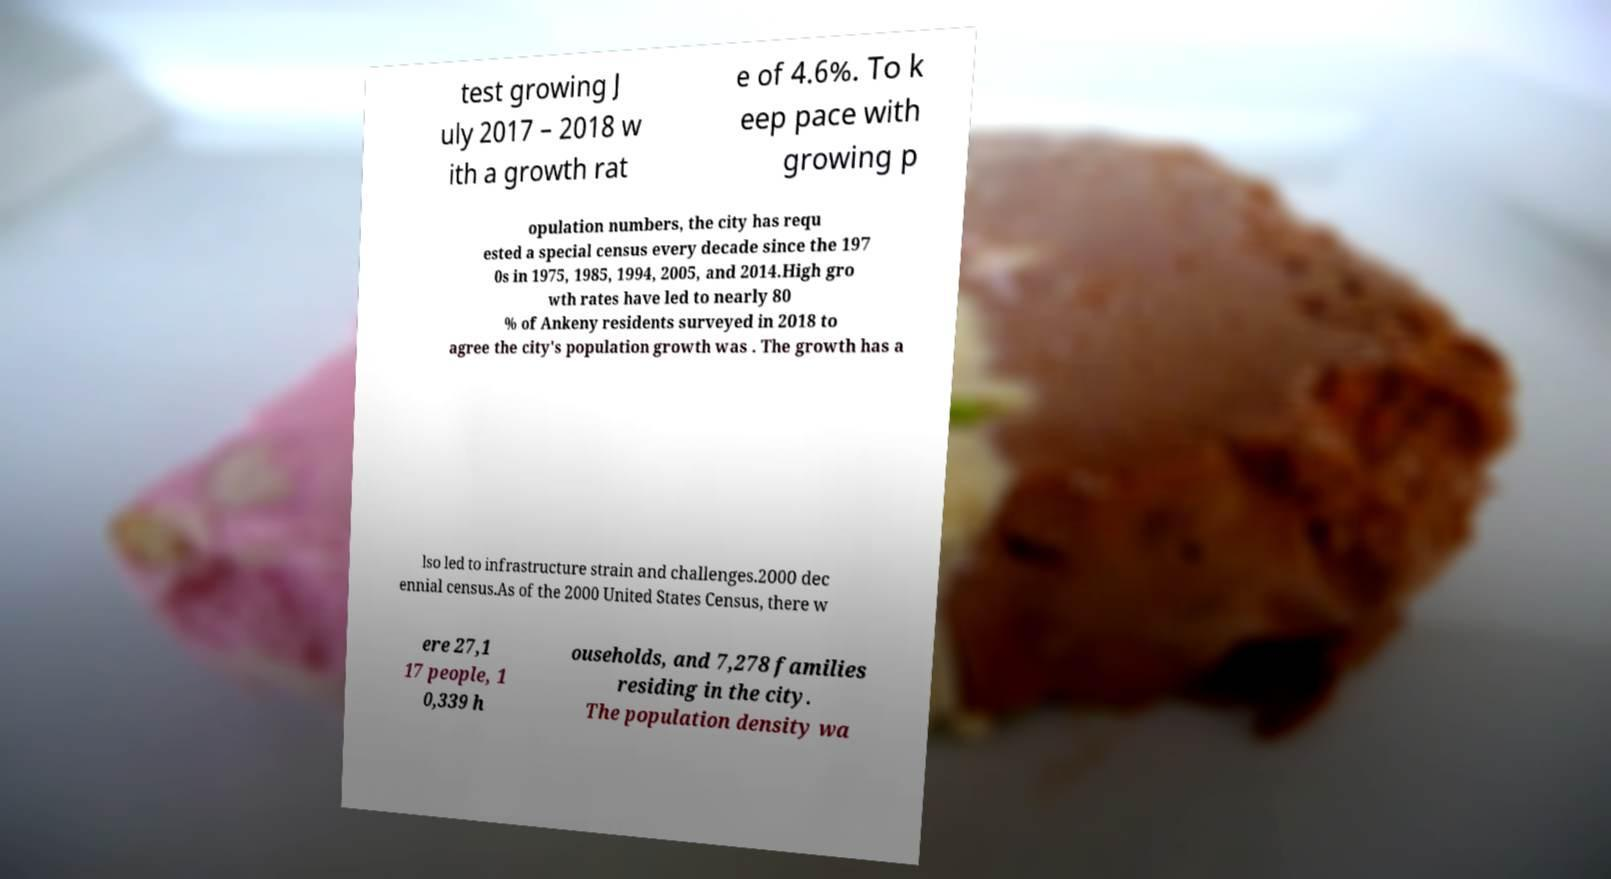Please read and relay the text visible in this image. What does it say? test growing J uly 2017 – 2018 w ith a growth rat e of 4.6%. To k eep pace with growing p opulation numbers, the city has requ ested a special census every decade since the 197 0s in 1975, 1985, 1994, 2005, and 2014.High gro wth rates have led to nearly 80 % of Ankeny residents surveyed in 2018 to agree the city's population growth was . The growth has a lso led to infrastructure strain and challenges.2000 dec ennial census.As of the 2000 United States Census, there w ere 27,1 17 people, 1 0,339 h ouseholds, and 7,278 families residing in the city. The population density wa 